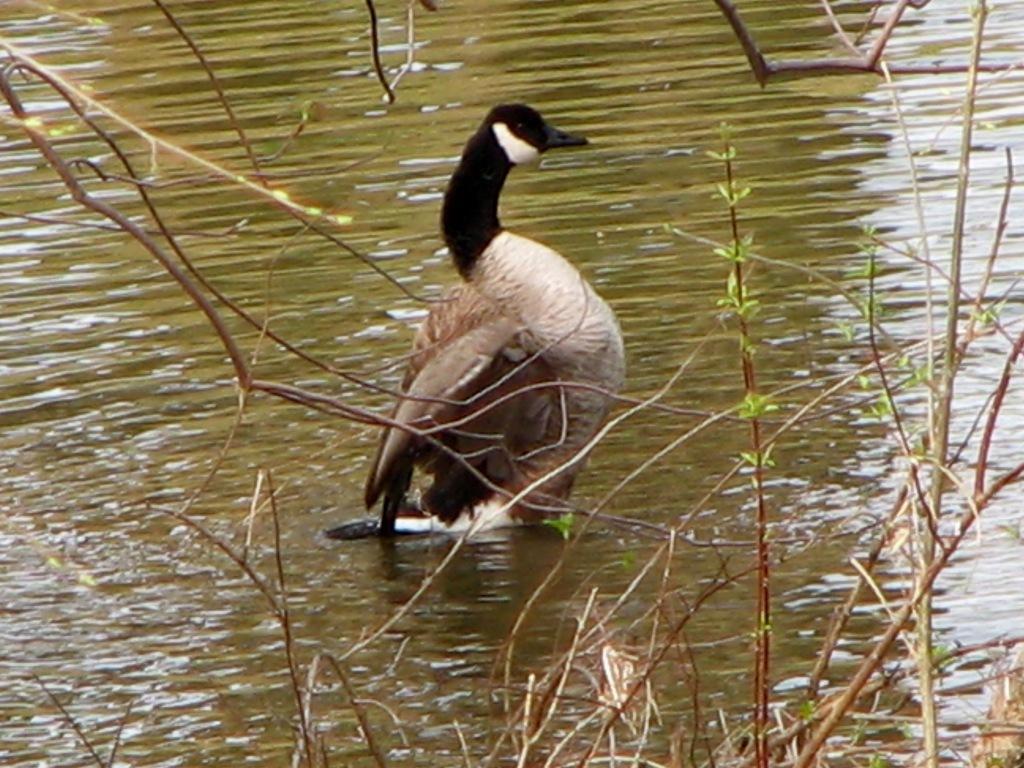How would you summarize this image in a sentence or two? In this image we can see a duck on the surface of the water. We can also see some plants. 